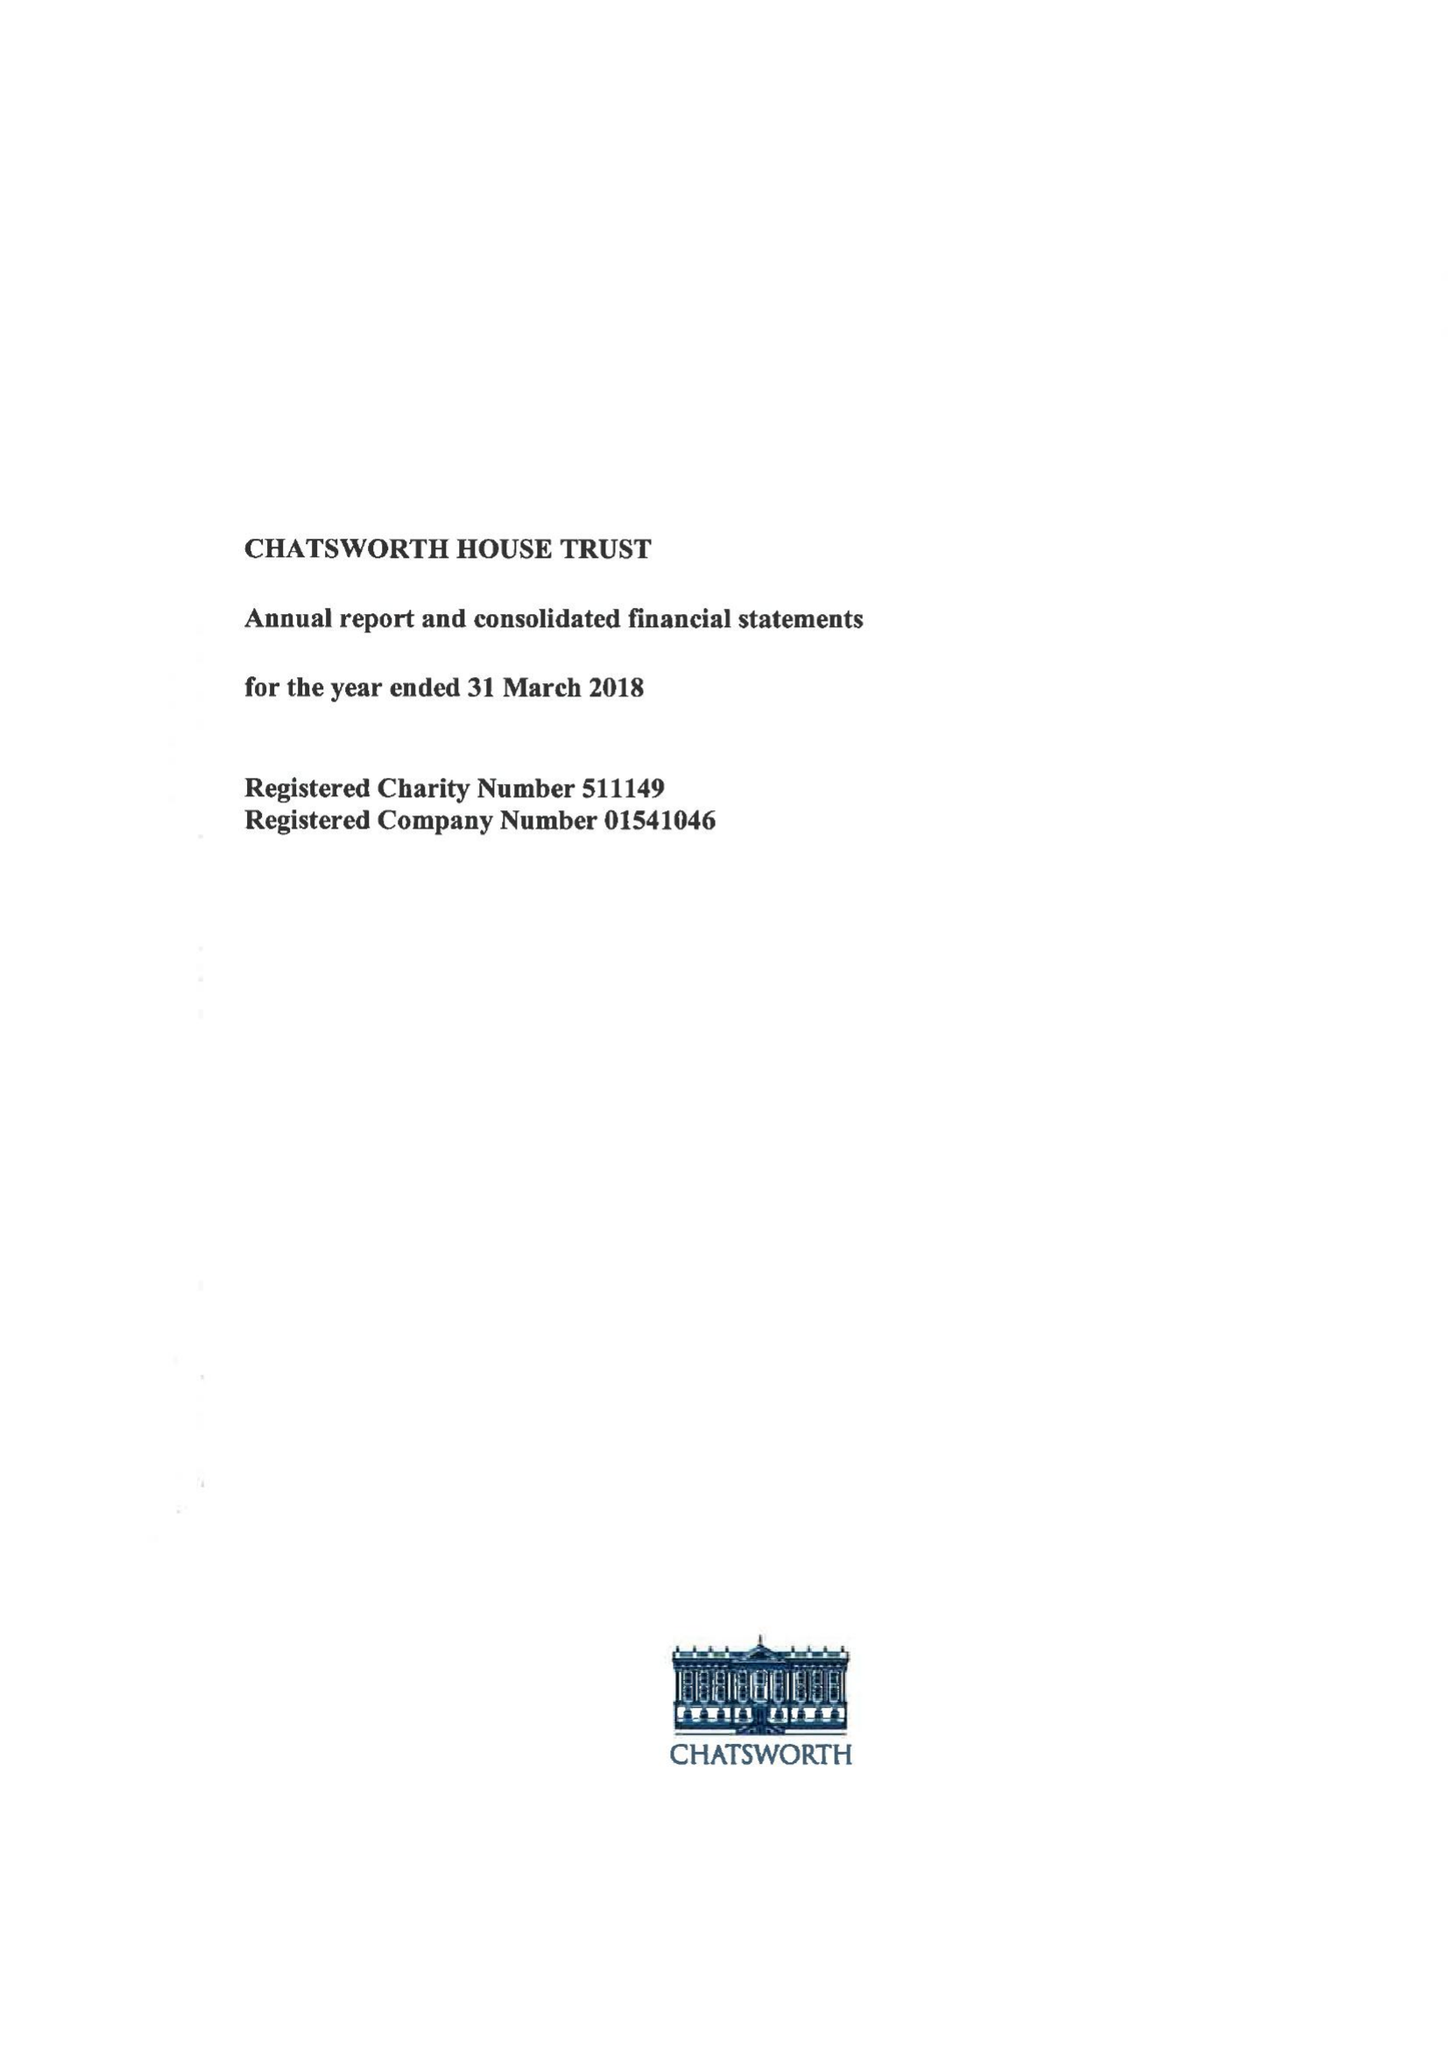What is the value for the charity_name?
Answer the question using a single word or phrase. Chatsworth House Trust 